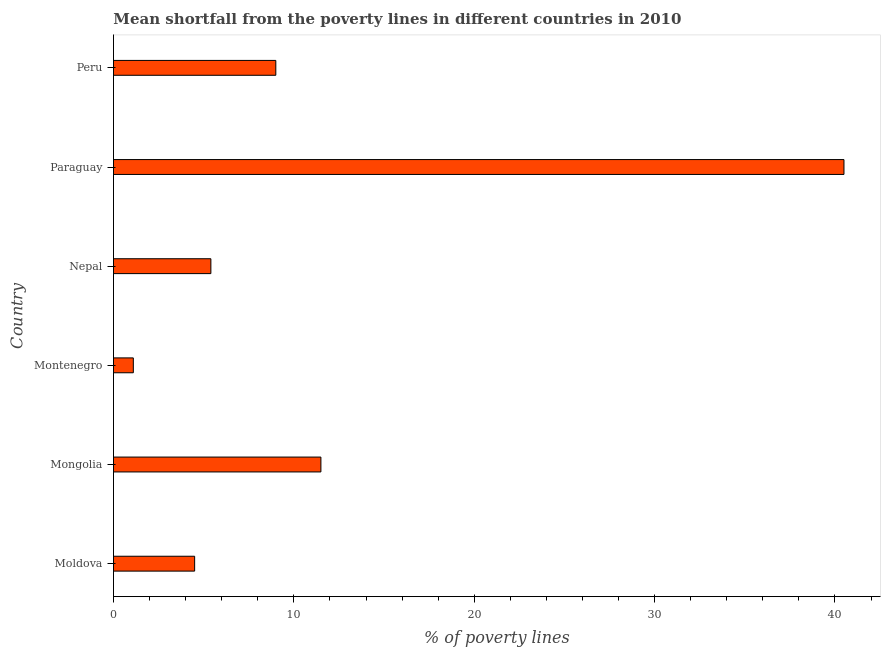Does the graph contain any zero values?
Your response must be concise. No. Does the graph contain grids?
Provide a short and direct response. No. What is the title of the graph?
Ensure brevity in your answer.  Mean shortfall from the poverty lines in different countries in 2010. What is the label or title of the X-axis?
Provide a short and direct response. % of poverty lines. What is the poverty gap at national poverty lines in Montenegro?
Give a very brief answer. 1.1. Across all countries, what is the maximum poverty gap at national poverty lines?
Make the answer very short. 40.5. Across all countries, what is the minimum poverty gap at national poverty lines?
Make the answer very short. 1.1. In which country was the poverty gap at national poverty lines maximum?
Offer a terse response. Paraguay. In which country was the poverty gap at national poverty lines minimum?
Offer a very short reply. Montenegro. What is the sum of the poverty gap at national poverty lines?
Keep it short and to the point. 72. What is the median poverty gap at national poverty lines?
Your answer should be compact. 7.2. What is the ratio of the poverty gap at national poverty lines in Mongolia to that in Nepal?
Keep it short and to the point. 2.13. Is the difference between the poverty gap at national poverty lines in Moldova and Paraguay greater than the difference between any two countries?
Your answer should be compact. No. Is the sum of the poverty gap at national poverty lines in Moldova and Nepal greater than the maximum poverty gap at national poverty lines across all countries?
Provide a short and direct response. No. What is the difference between the highest and the lowest poverty gap at national poverty lines?
Make the answer very short. 39.4. How many countries are there in the graph?
Ensure brevity in your answer.  6. What is the difference between two consecutive major ticks on the X-axis?
Offer a terse response. 10. Are the values on the major ticks of X-axis written in scientific E-notation?
Make the answer very short. No. What is the % of poverty lines in Moldova?
Make the answer very short. 4.5. What is the % of poverty lines in Paraguay?
Ensure brevity in your answer.  40.5. What is the % of poverty lines of Peru?
Ensure brevity in your answer.  9. What is the difference between the % of poverty lines in Moldova and Mongolia?
Provide a succinct answer. -7. What is the difference between the % of poverty lines in Moldova and Montenegro?
Provide a short and direct response. 3.4. What is the difference between the % of poverty lines in Moldova and Nepal?
Your answer should be compact. -0.9. What is the difference between the % of poverty lines in Moldova and Paraguay?
Give a very brief answer. -36. What is the difference between the % of poverty lines in Moldova and Peru?
Ensure brevity in your answer.  -4.5. What is the difference between the % of poverty lines in Mongolia and Nepal?
Your response must be concise. 6.1. What is the difference between the % of poverty lines in Montenegro and Nepal?
Provide a succinct answer. -4.3. What is the difference between the % of poverty lines in Montenegro and Paraguay?
Provide a succinct answer. -39.4. What is the difference between the % of poverty lines in Nepal and Paraguay?
Make the answer very short. -35.1. What is the difference between the % of poverty lines in Nepal and Peru?
Keep it short and to the point. -3.6. What is the difference between the % of poverty lines in Paraguay and Peru?
Make the answer very short. 31.5. What is the ratio of the % of poverty lines in Moldova to that in Mongolia?
Offer a terse response. 0.39. What is the ratio of the % of poverty lines in Moldova to that in Montenegro?
Your answer should be compact. 4.09. What is the ratio of the % of poverty lines in Moldova to that in Nepal?
Your answer should be compact. 0.83. What is the ratio of the % of poverty lines in Moldova to that in Paraguay?
Your answer should be compact. 0.11. What is the ratio of the % of poverty lines in Mongolia to that in Montenegro?
Your answer should be compact. 10.46. What is the ratio of the % of poverty lines in Mongolia to that in Nepal?
Give a very brief answer. 2.13. What is the ratio of the % of poverty lines in Mongolia to that in Paraguay?
Give a very brief answer. 0.28. What is the ratio of the % of poverty lines in Mongolia to that in Peru?
Provide a succinct answer. 1.28. What is the ratio of the % of poverty lines in Montenegro to that in Nepal?
Your response must be concise. 0.2. What is the ratio of the % of poverty lines in Montenegro to that in Paraguay?
Your response must be concise. 0.03. What is the ratio of the % of poverty lines in Montenegro to that in Peru?
Offer a terse response. 0.12. What is the ratio of the % of poverty lines in Nepal to that in Paraguay?
Keep it short and to the point. 0.13. 